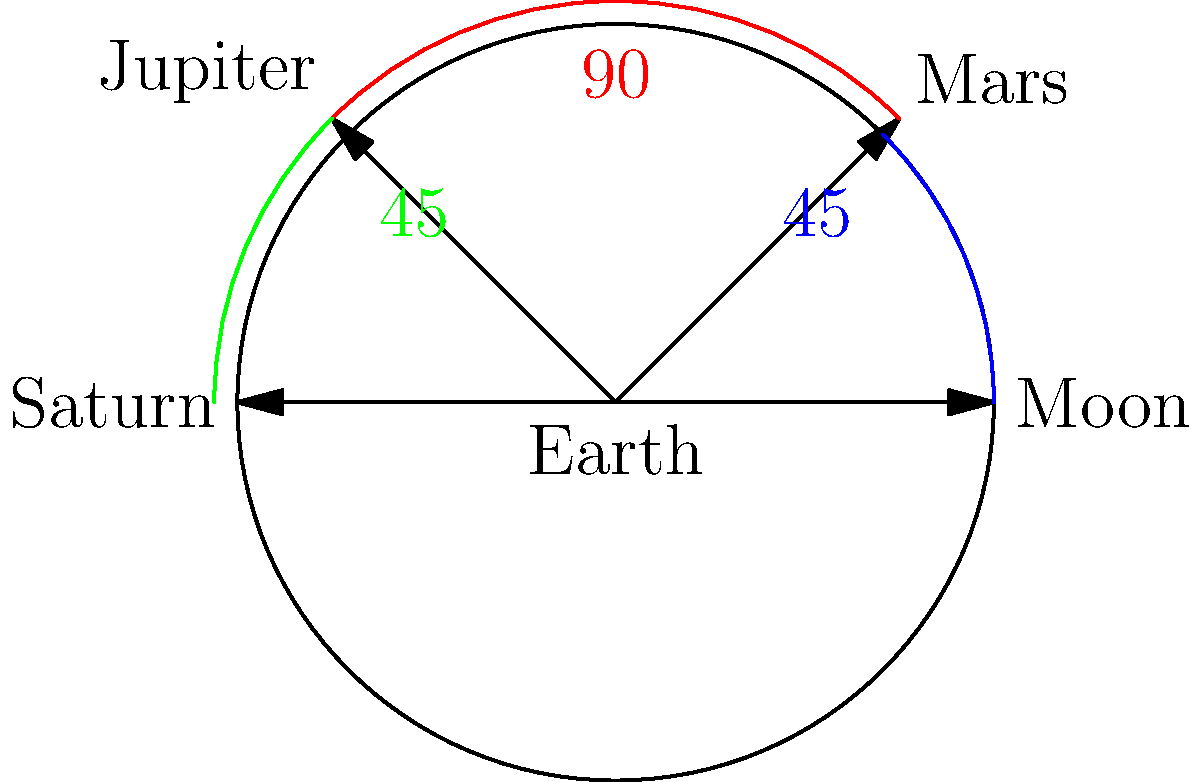In a science fiction film, a spaceship travels from Earth to Saturn, passing by the Moon, Mars, and Jupiter along the way. The film claims that the angular separation between each consecutive celestial body is 60°. Using the provided diagram, which shows the actual angular separations, calculate the total angular distance traveled by the spaceship from Earth to Saturn. How does this compare to the film's depiction, and what percentage error does the film make? Let's approach this step-by-step:

1) From the diagram, we can see the actual angular separations:
   - Earth to Moon: 45°
   - Moon to Mars: 45°
   - Mars to Jupiter: 90°
   - Jupiter to Saturn: 45°

2) The total actual angular distance is:
   $45° + 45° + 90° + 45° = 225°$

3) In the film, each separation is claimed to be 60°. With 4 separations, the total angular distance in the film would be:
   $60° \times 4 = 240°$

4) To calculate the percentage error:
   
   Percentage Error = $\frac{|Measured - Actual|}{Actual} \times 100\%$
   
   $= \frac{|240° - 225°|}{225°} \times 100\%$
   
   $= \frac{15°}{225°} \times 100\%$
   
   $= 0.0667 \times 100\% = 6.67\%$

5) The film overestimates the angular distance by 15° or 6.67%.
Answer: 225°; film overestimates by 6.67% 